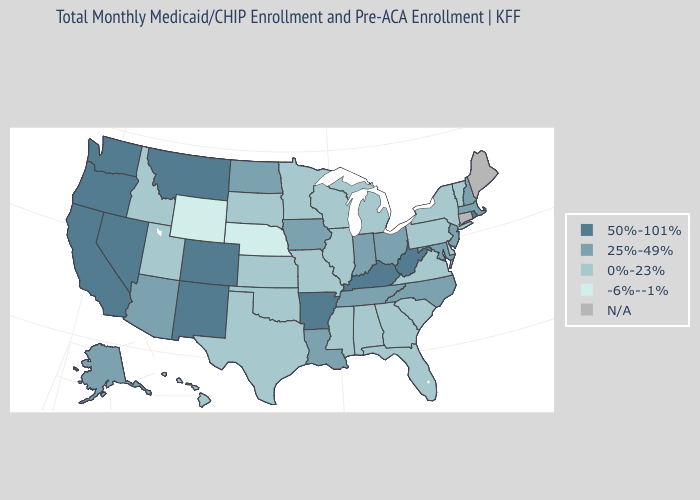What is the highest value in the USA?
Concise answer only. 50%-101%. Name the states that have a value in the range N/A?
Quick response, please. Connecticut, Maine. Among the states that border Texas , which have the highest value?
Short answer required. Arkansas, New Mexico. What is the value of Maryland?
Give a very brief answer. 25%-49%. What is the value of New Mexico?
Write a very short answer. 50%-101%. Does Alaska have the highest value in the West?
Be succinct. No. Does the map have missing data?
Keep it brief. Yes. Does New Mexico have the lowest value in the USA?
Be succinct. No. Name the states that have a value in the range 25%-49%?
Concise answer only. Alaska, Arizona, Indiana, Iowa, Louisiana, Maryland, Massachusetts, New Hampshire, New Jersey, North Carolina, North Dakota, Ohio, Tennessee. What is the value of Illinois?
Quick response, please. 0%-23%. Name the states that have a value in the range N/A?
Be succinct. Connecticut, Maine. 